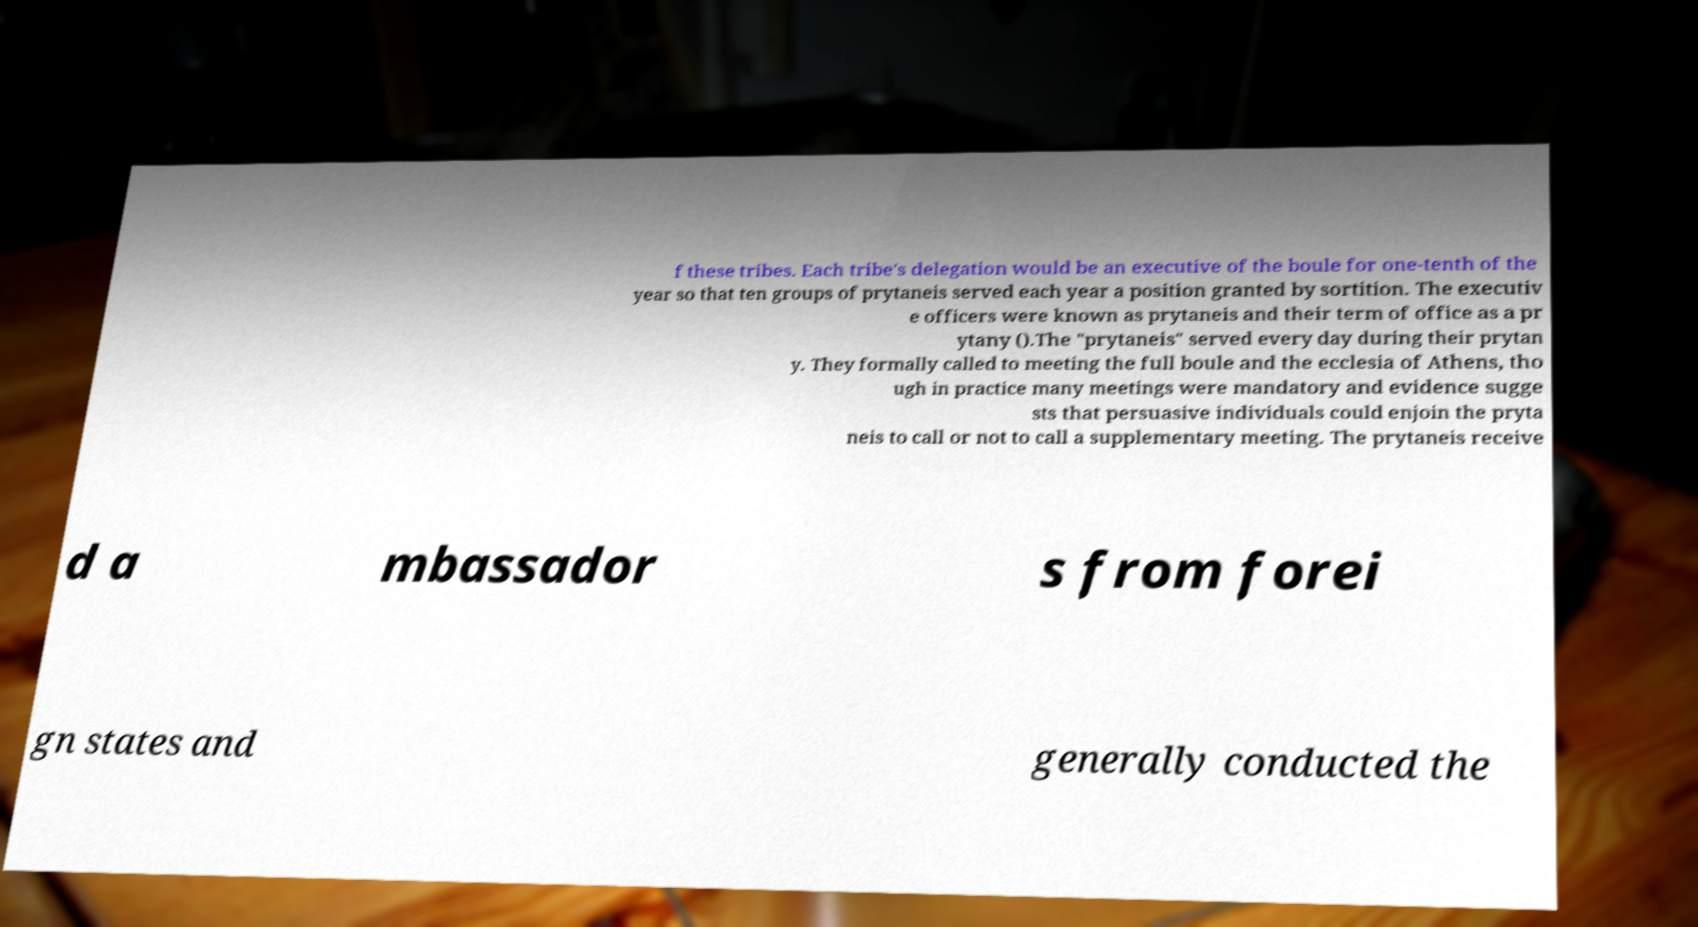Could you extract and type out the text from this image? f these tribes. Each tribe's delegation would be an executive of the boule for one-tenth of the year so that ten groups of prytaneis served each year a position granted by sortition. The executiv e officers were known as prytaneis and their term of office as a pr ytany ().The "prytaneis" served every day during their prytan y. They formally called to meeting the full boule and the ecclesia of Athens, tho ugh in practice many meetings were mandatory and evidence sugge sts that persuasive individuals could enjoin the pryta neis to call or not to call a supplementary meeting. The prytaneis receive d a mbassador s from forei gn states and generally conducted the 